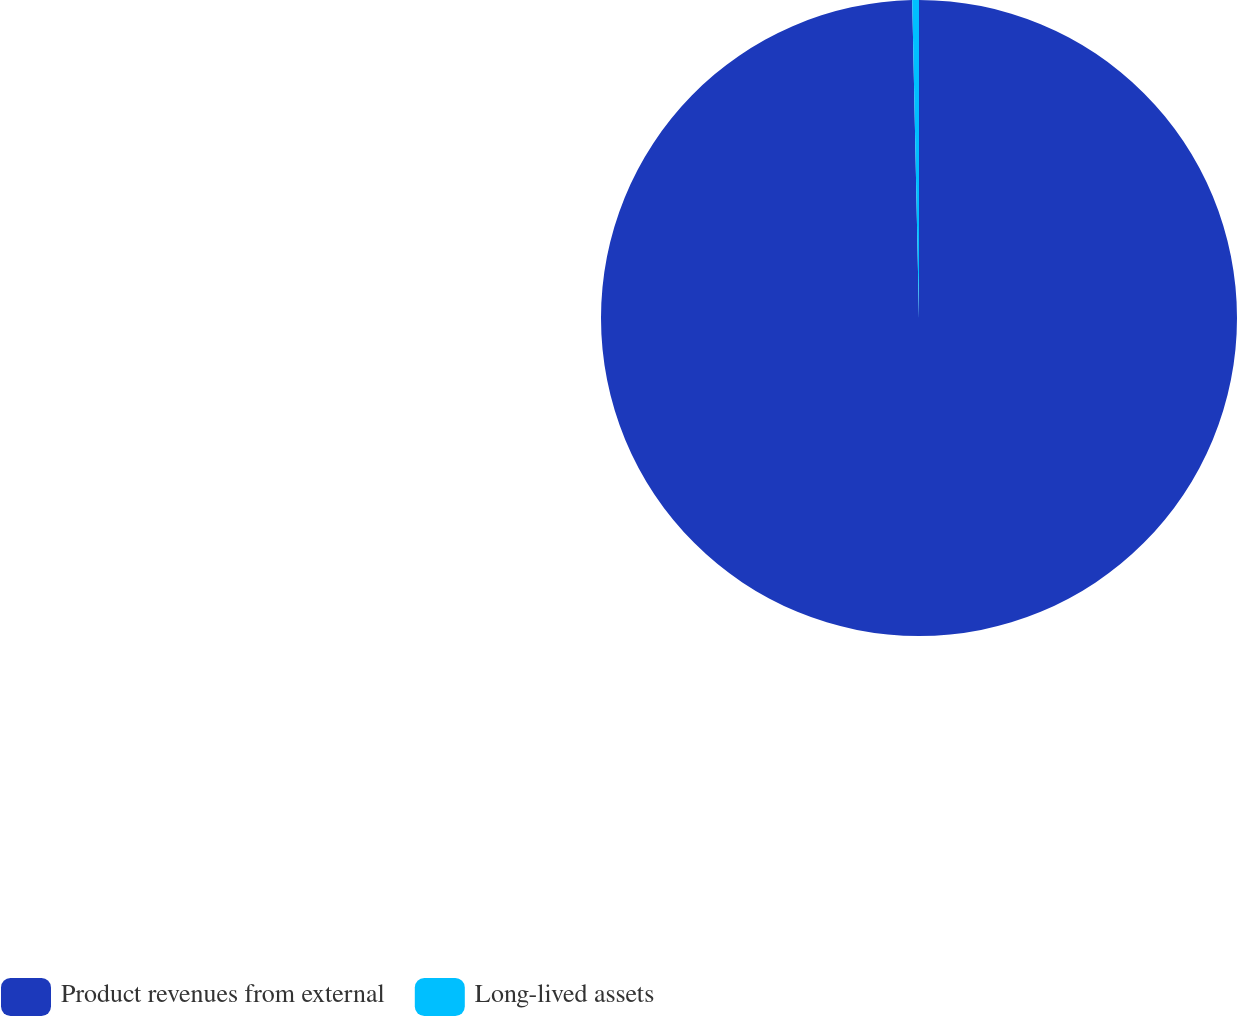Convert chart to OTSL. <chart><loc_0><loc_0><loc_500><loc_500><pie_chart><fcel>Product revenues from external<fcel>Long-lived assets<nl><fcel>99.66%<fcel>0.34%<nl></chart> 